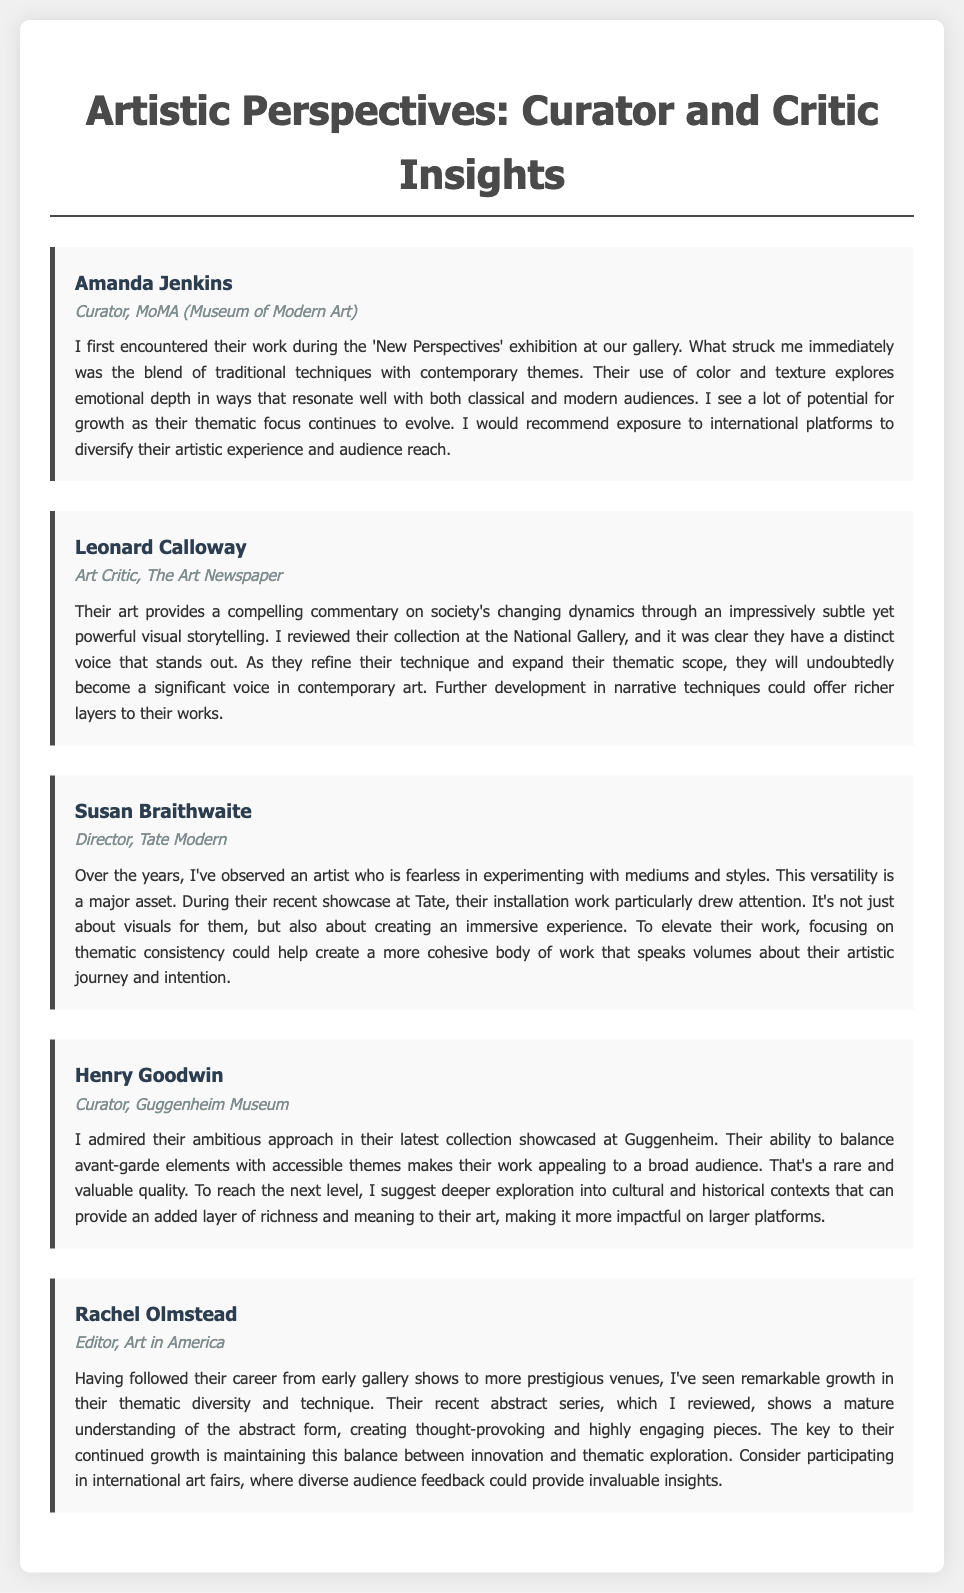what is the name of the curator from MoMA? The curator from MoMA who reviewed the work is Amanda Jenkins.
Answer: Amanda Jenkins what is the main quality admired by Henry Goodwin? Henry Goodwin admired the artist's ability to balance avant-garde elements with accessible themes.
Answer: Balancing avant-garde elements with accessible themes which art critic recognized the artist's distinct voice? Leonard Calloway recognized that the artist has a distinct voice that stands out.
Answer: Leonard Calloway what does Susan Braithwaite suggest for the artist to elevate their work? Susan Braithwaite suggests focusing on thematic consistency to help create a more cohesive body of work.
Answer: Thematic consistency how many interviews are included in the document? The number of interviews presented in the document is five.
Answer: Five what is Rachel Olmstead's position? Rachel Olmstead's position is Editor of Art in America.
Answer: Editor what type of work drew attention at Tate according to Susan Braithwaite? According to Susan Braithwaite, the installation work drew attention at Tate.
Answer: Installation work what recommendation does Amanda Jenkins give to the artist for future growth? Amanda Jenkins recommends exposure to international platforms to diversify their artistic experience.
Answer: Exposure to international platforms what is a key aspect of the recent abstract series mentioned by Rachel Olmstead? A key aspect mentioned by Rachel Olmstead is the mature understanding of the abstract form.
Answer: Mature understanding of the abstract form 